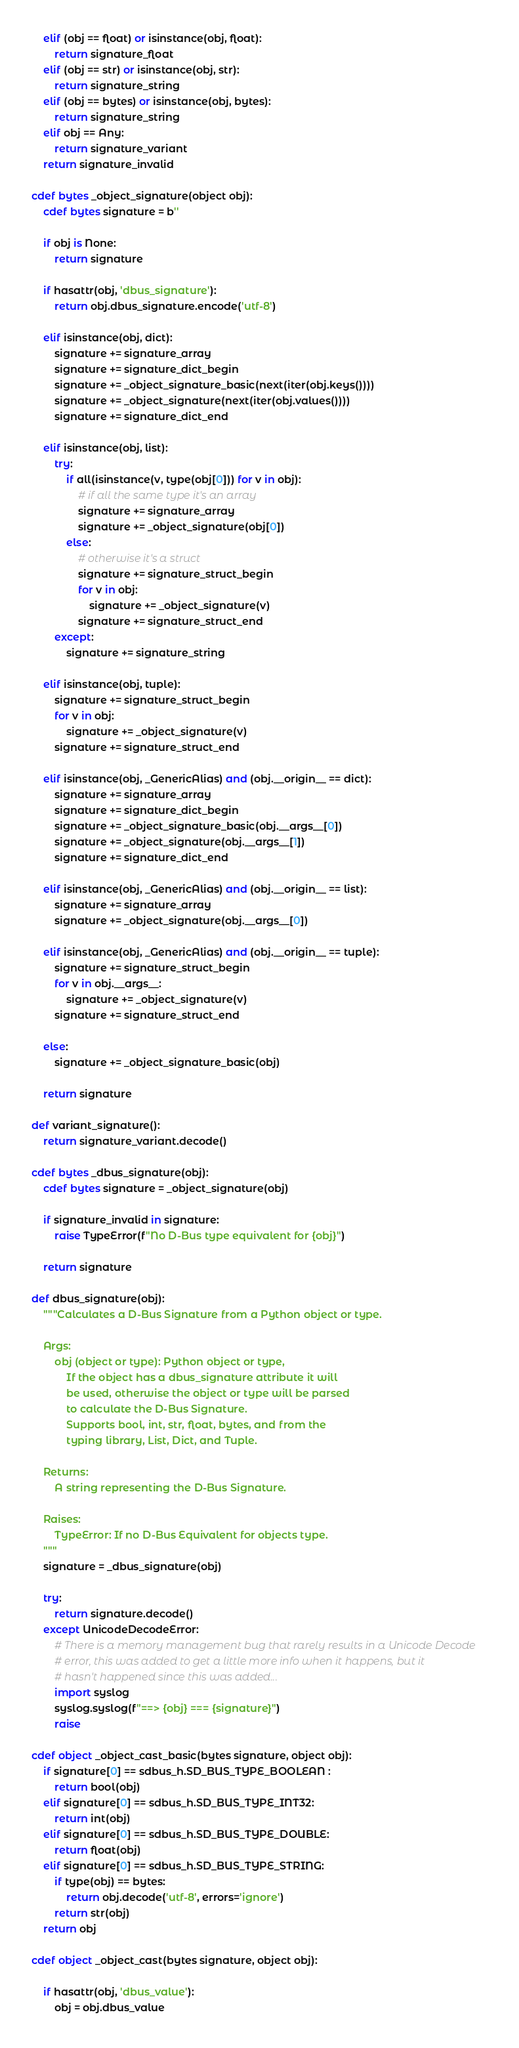<code> <loc_0><loc_0><loc_500><loc_500><_Cython_>    elif (obj == float) or isinstance(obj, float):
        return signature_float
    elif (obj == str) or isinstance(obj, str):
        return signature_string
    elif (obj == bytes) or isinstance(obj, bytes):
        return signature_string
    elif obj == Any:
        return signature_variant
    return signature_invalid

cdef bytes _object_signature(object obj):
    cdef bytes signature = b''

    if obj is None:
        return signature

    if hasattr(obj, 'dbus_signature'):
        return obj.dbus_signature.encode('utf-8')

    elif isinstance(obj, dict):
        signature += signature_array
        signature += signature_dict_begin
        signature += _object_signature_basic(next(iter(obj.keys())))
        signature += _object_signature(next(iter(obj.values())))
        signature += signature_dict_end

    elif isinstance(obj, list):
        try:
            if all(isinstance(v, type(obj[0])) for v in obj):
                # if all the same type it's an array
                signature += signature_array
                signature += _object_signature(obj[0])
            else:
                # otherwise it's a struct
                signature += signature_struct_begin
                for v in obj:
                    signature += _object_signature(v)
                signature += signature_struct_end
        except:
            signature += signature_string

    elif isinstance(obj, tuple):
        signature += signature_struct_begin
        for v in obj:
            signature += _object_signature(v)
        signature += signature_struct_end

    elif isinstance(obj, _GenericAlias) and (obj.__origin__ == dict):
        signature += signature_array
        signature += signature_dict_begin
        signature += _object_signature_basic(obj.__args__[0])
        signature += _object_signature(obj.__args__[1])
        signature += signature_dict_end

    elif isinstance(obj, _GenericAlias) and (obj.__origin__ == list):
        signature += signature_array
        signature += _object_signature(obj.__args__[0])

    elif isinstance(obj, _GenericAlias) and (obj.__origin__ == tuple):
        signature += signature_struct_begin
        for v in obj.__args__:
            signature += _object_signature(v)
        signature += signature_struct_end

    else:
        signature += _object_signature_basic(obj)

    return signature

def variant_signature():
    return signature_variant.decode()

cdef bytes _dbus_signature(obj):
    cdef bytes signature = _object_signature(obj)

    if signature_invalid in signature:
        raise TypeError(f"No D-Bus type equivalent for {obj}")

    return signature

def dbus_signature(obj):
    """Calculates a D-Bus Signature from a Python object or type.

    Args:
        obj (object or type): Python object or type,
            If the object has a dbus_signature attribute it will
            be used, otherwise the object or type will be parsed
            to calculate the D-Bus Signature.
            Supports bool, int, str, float, bytes, and from the
            typing library, List, Dict, and Tuple.

    Returns:
        A string representing the D-Bus Signature.

    Raises:
        TypeError: If no D-Bus Equivalent for objects type.
    """
    signature = _dbus_signature(obj)

    try:
        return signature.decode()
    except UnicodeDecodeError:
        # There is a memory management bug that rarely results in a Unicode Decode
        # error, this was added to get a little more info when it happens, but it
        # hasn't happened since this was added...
        import syslog
        syslog.syslog(f"==> {obj} === {signature}")
        raise

cdef object _object_cast_basic(bytes signature, object obj):
    if signature[0] == sdbus_h.SD_BUS_TYPE_BOOLEAN :
        return bool(obj)
    elif signature[0] == sdbus_h.SD_BUS_TYPE_INT32:
        return int(obj)
    elif signature[0] == sdbus_h.SD_BUS_TYPE_DOUBLE:
        return float(obj)
    elif signature[0] == sdbus_h.SD_BUS_TYPE_STRING:
        if type(obj) == bytes:
            return obj.decode('utf-8', errors='ignore')
        return str(obj)
    return obj

cdef object _object_cast(bytes signature, object obj):

    if hasattr(obj, 'dbus_value'):
        obj = obj.dbus_value
</code> 